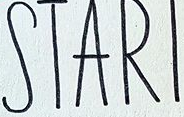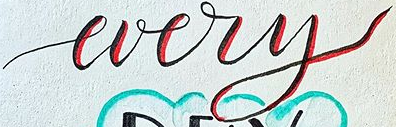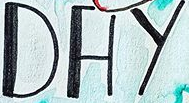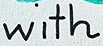What words can you see in these images in sequence, separated by a semicolon? STARI; every; DAY; with 